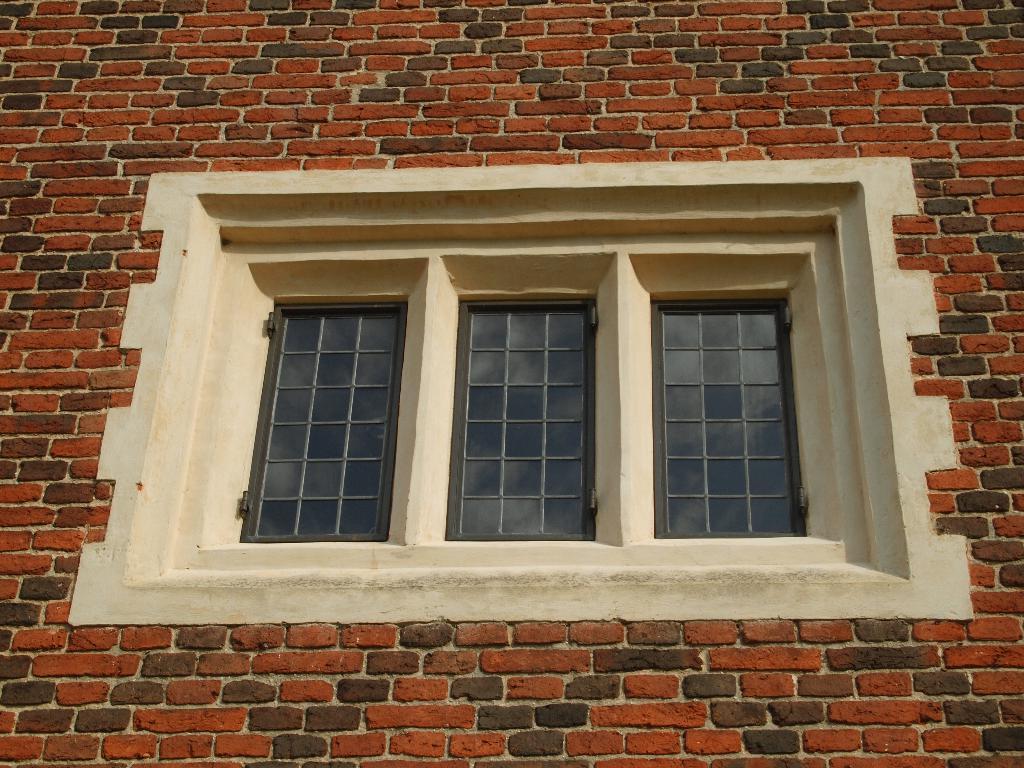Could you give a brief overview of what you see in this image? In this picture we can see a wall, windows and metal rods, in the mirror reflection we can see clouds. 